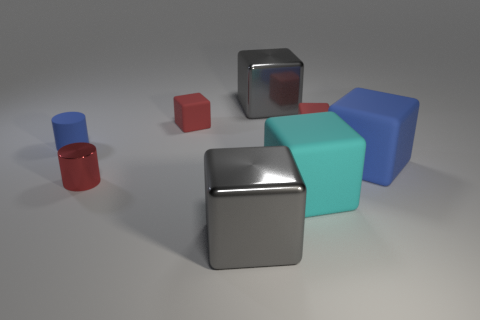Are there an equal number of large cyan matte cubes left of the shiny cylinder and big gray metal things?
Provide a short and direct response. No. What number of small gray rubber objects are there?
Your answer should be very brief. 0. What is the shape of the metallic object that is both behind the cyan cube and in front of the large blue rubber block?
Your response must be concise. Cylinder. There is a big rubber object behind the red metallic object; does it have the same color as the metallic object behind the tiny blue rubber cylinder?
Give a very brief answer. No. What size is the cube that is the same color as the rubber cylinder?
Keep it short and to the point. Large. Is there another big cyan block that has the same material as the big cyan cube?
Your answer should be compact. No. Are there an equal number of tiny cylinders that are in front of the big cyan matte object and large shiny cubes behind the blue rubber cylinder?
Your answer should be very brief. No. How big is the blue matte thing that is in front of the blue cylinder?
Your answer should be very brief. Large. What material is the large cube to the left of the gray object that is behind the small red shiny thing?
Provide a short and direct response. Metal. There is a big gray metal object in front of the red metal thing on the right side of the matte cylinder; how many small matte objects are right of it?
Your answer should be compact. 1. 